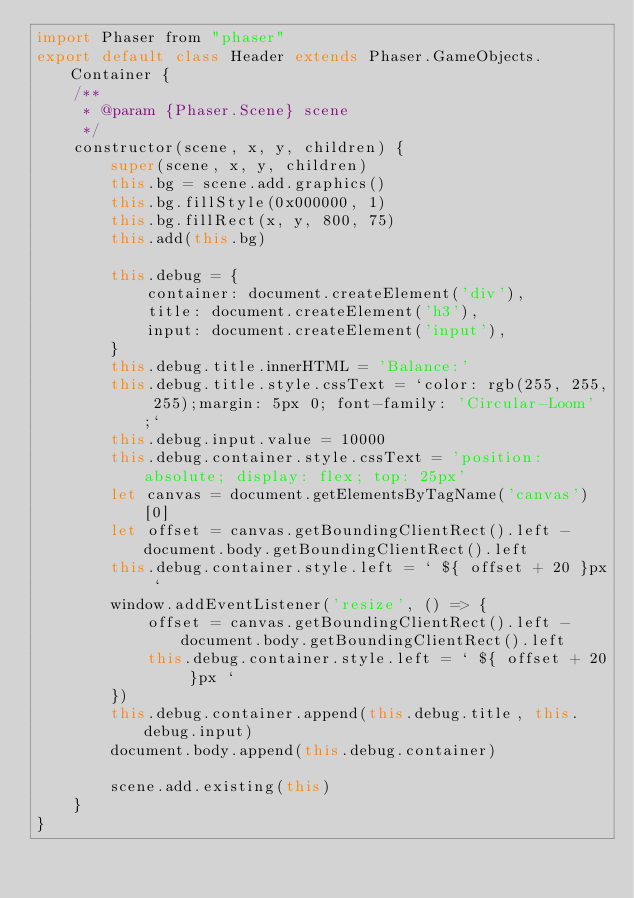<code> <loc_0><loc_0><loc_500><loc_500><_JavaScript_>import Phaser from "phaser"
export default class Header extends Phaser.GameObjects.Container {
    /**
     * @param {Phaser.Scene} scene
     */
    constructor(scene, x, y, children) {
        super(scene, x, y, children)
        this.bg = scene.add.graphics()
        this.bg.fillStyle(0x000000, 1)
        this.bg.fillRect(x, y, 800, 75)
        this.add(this.bg)

        this.debug = {
            container: document.createElement('div'),
            title: document.createElement('h3'),
            input: document.createElement('input'),
        }
        this.debug.title.innerHTML = 'Balance:'
        this.debug.title.style.cssText = `color: rgb(255, 255, 255);margin: 5px 0; font-family: 'Circular-Loom';`
        this.debug.input.value = 10000
        this.debug.container.style.cssText = 'position: absolute; display: flex; top: 25px'
        let canvas = document.getElementsByTagName('canvas')[0]
        let offset = canvas.getBoundingClientRect().left - document.body.getBoundingClientRect().left
        this.debug.container.style.left = ` ${ offset + 20 }px `
        window.addEventListener('resize', () => {
            offset = canvas.getBoundingClientRect().left - document.body.getBoundingClientRect().left
            this.debug.container.style.left = ` ${ offset + 20 }px `
        })
        this.debug.container.append(this.debug.title, this.debug.input)
        document.body.append(this.debug.container)

        scene.add.existing(this)
    }
}</code> 